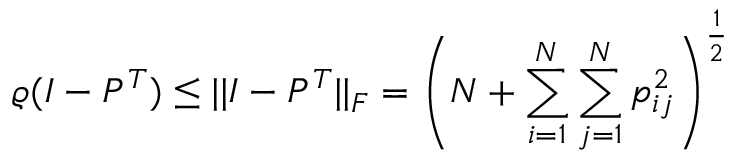Convert formula to latex. <formula><loc_0><loc_0><loc_500><loc_500>\varrho ( I - P ^ { T } ) \leq | | I - P ^ { T } | | _ { F } = \left ( N + \sum _ { i = 1 } ^ { N } \sum _ { j = 1 } ^ { N } p _ { i j } ^ { 2 } \right ) ^ { \frac { 1 } { 2 } }</formula> 